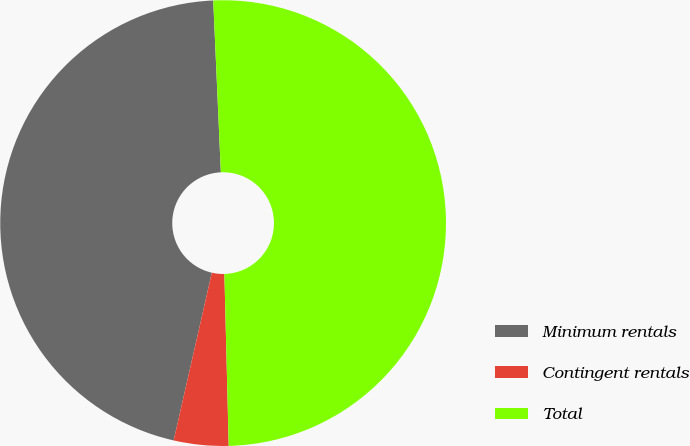Convert chart. <chart><loc_0><loc_0><loc_500><loc_500><pie_chart><fcel>Minimum rentals<fcel>Contingent rentals<fcel>Total<nl><fcel>45.73%<fcel>3.96%<fcel>50.3%<nl></chart> 